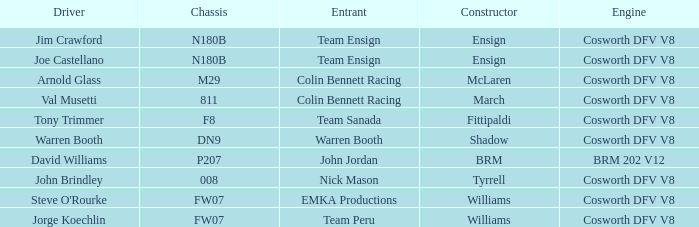What chassis does the shadow built car use? DN9. 